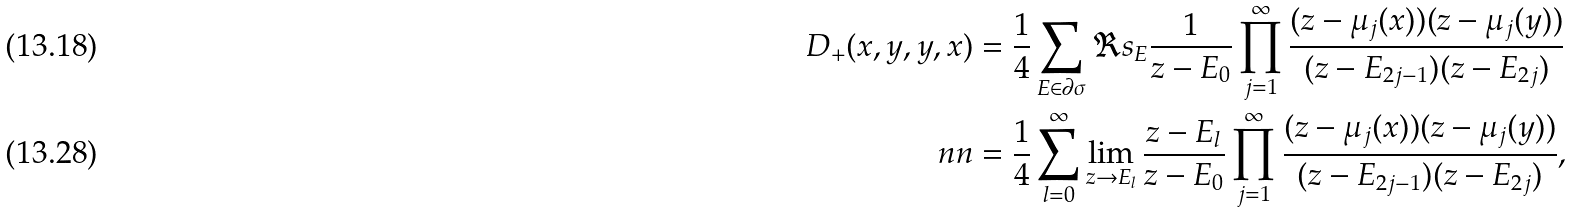<formula> <loc_0><loc_0><loc_500><loc_500>D _ { + } ( x , y , y , x ) & = \frac { 1 } { 4 } \sum _ { E \in \partial \sigma } \Re s _ { E } \frac { 1 } { z - E _ { 0 } } \prod _ { j = 1 } ^ { \infty } \frac { ( z - \mu _ { j } ( x ) ) ( z - \mu _ { j } ( y ) ) } { ( z - E _ { 2 j - 1 } ) ( z - E _ { 2 j } ) } \\ \ n n & = \frac { 1 } { 4 } \sum _ { l = 0 } ^ { \infty } \lim _ { z \to E _ { l } } \frac { z - E _ { l } } { z - E _ { 0 } } \prod _ { j = 1 } ^ { \infty } \frac { ( z - \mu _ { j } ( x ) ) ( z - \mu _ { j } ( y ) ) } { ( z - E _ { 2 j - 1 } ) ( z - E _ { 2 j } ) } ,</formula> 